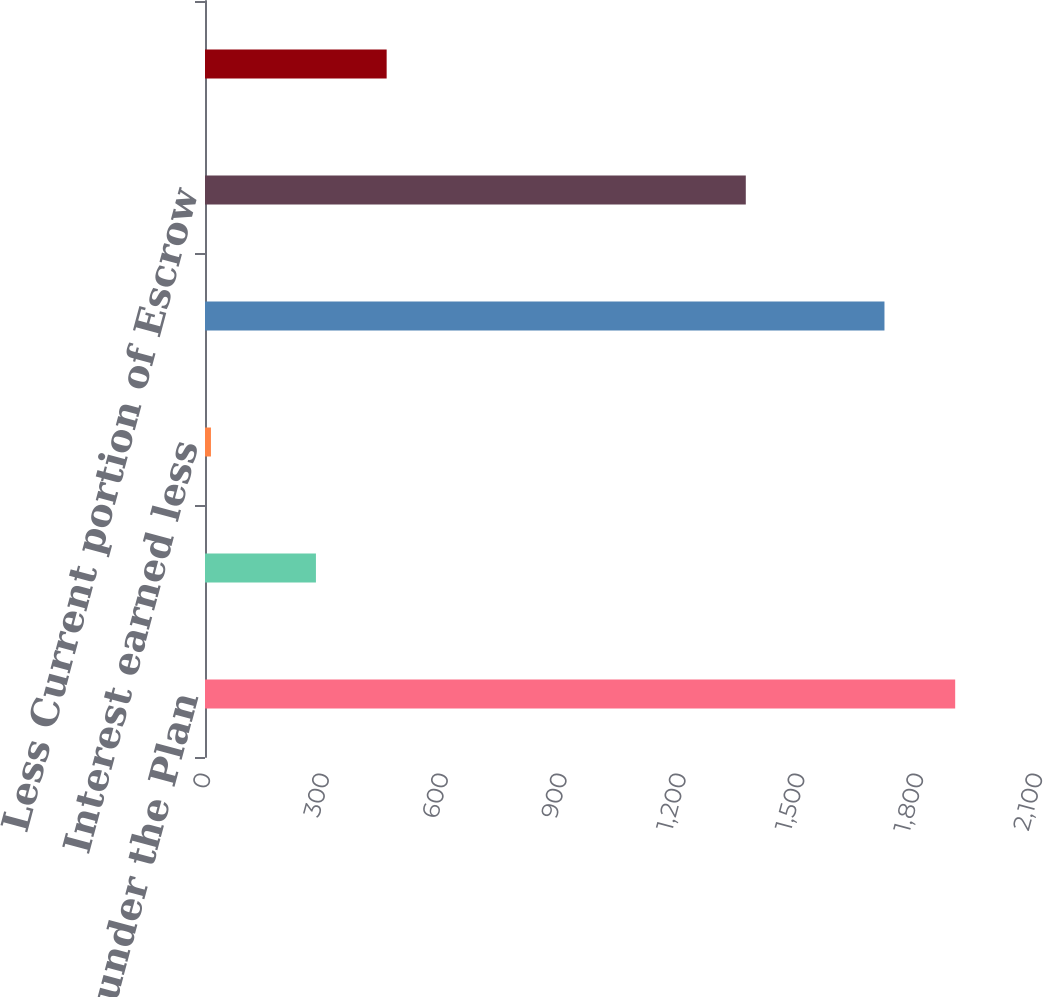<chart> <loc_0><loc_0><loc_500><loc_500><bar_chart><fcel>Funding under the Plan<fcel>American Express settlement<fcel>Interest earned less<fcel>Balance at September 30<fcel>Less Current portion of Escrow<fcel>Long-term portion of Escrow<nl><fcel>1893.5<fcel>280<fcel>15<fcel>1715<fcel>1365<fcel>458.5<nl></chart> 